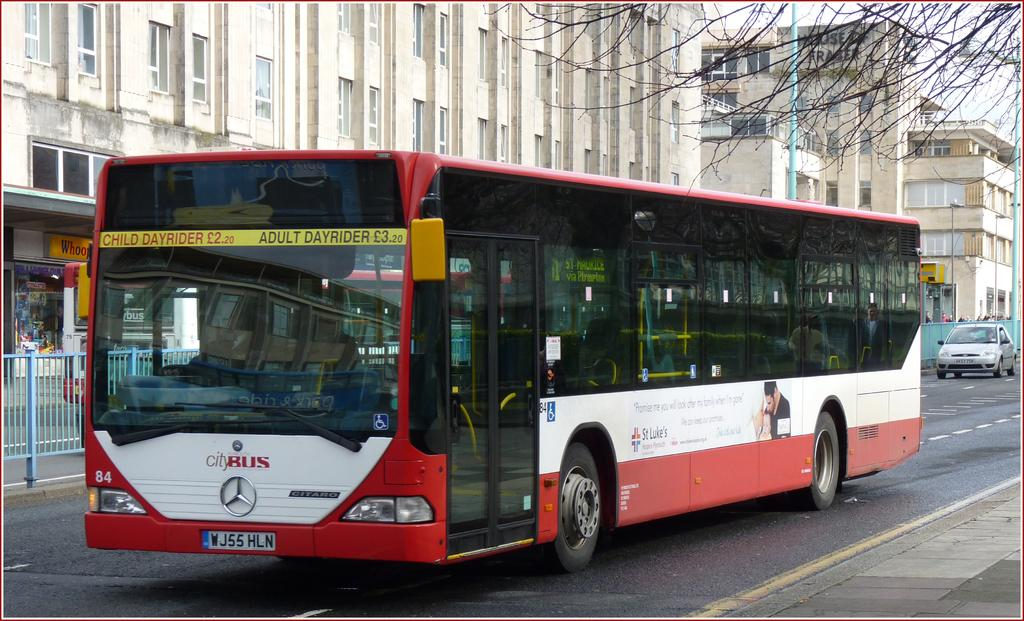What is the main subject in the center of the image? There is a bus in the center of the image. What can be seen in the background of the image? There are buildings, poles, trees, and a railing in the background of the image. What is at the bottom of the image? There is a road at the bottom of the image. Are there any vehicles visible in the image? Yes, there is a car on the right side of the image. What type of cookware is hanging from the line in the image? There is no line or cookware present in the image. What is the purpose of the bus in the image? The purpose of the bus in the image cannot be determined from the image alone. 